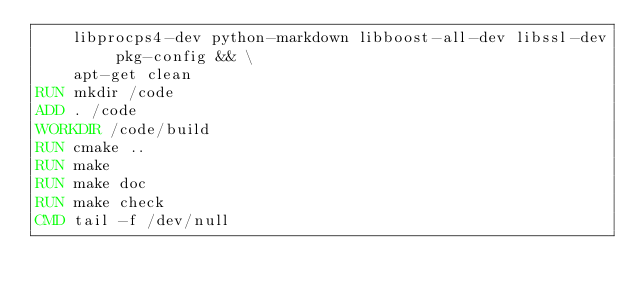<code> <loc_0><loc_0><loc_500><loc_500><_Dockerfile_>    libprocps4-dev python-markdown libboost-all-dev libssl-dev pkg-config && \
    apt-get clean
RUN mkdir /code
ADD . /code
WORKDIR /code/build 
RUN cmake ..
RUN make
RUN make doc
RUN make check
CMD tail -f /dev/null
</code> 